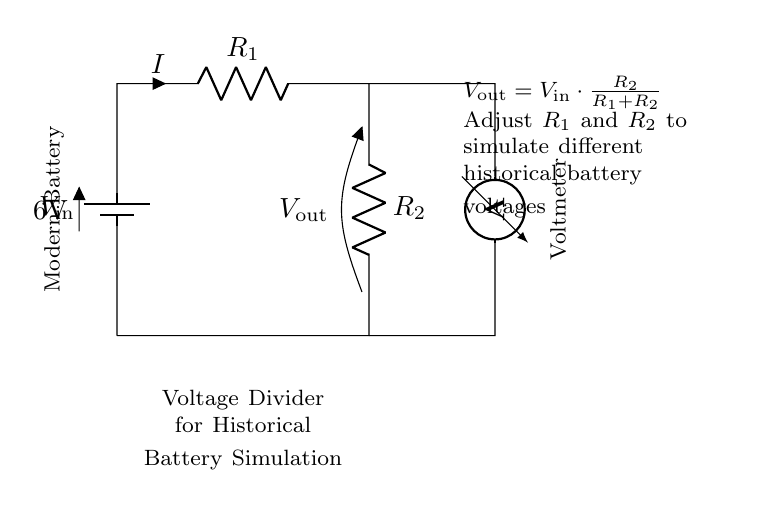What is the input voltage of the circuit? The input voltage is indicated as 6 volts on the battery notation in the circuit diagram.
Answer: 6 volts What type of circuit is illustrated here? The circuit is a voltage divider, as it is designed to divide the input voltage based on the resistor values.
Answer: Voltage divider What do R1 and R2 represent in this circuit? R1 and R2 represent resistors that are part of the voltage divider; their values affect the output voltage.
Answer: Resistors What is the formula for calculating the output voltage? The formula shown in the circuit diagram is V out = V in multiplied by R2 divided by the sum of R1 and R2, indicating how V out is derived from input and resistors.
Answer: V out = V in * (R2 / (R1 + R2)) How can the output voltage be adjusted in this circuit? The output voltage can be adjusted by changing the values of R1 and R2, as the voltage divider formula directly relates output to the resistor values.
Answer: Adjust R1 and R2 What does the voltmeter indicate in this circuit? The voltmeter measures the output voltage (V out) across R2, which shows the voltage after the division has taken place.
Answer: Output voltage 